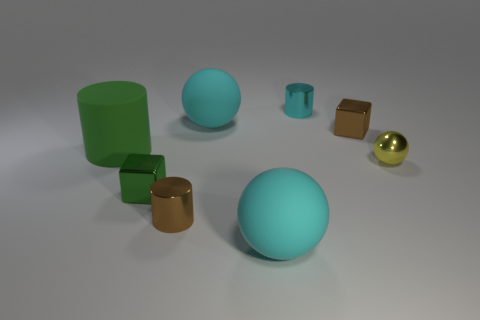Subtract all red cylinders. How many cyan spheres are left? 2 Subtract all cyan balls. How many balls are left? 1 Add 1 tiny cyan metallic objects. How many objects exist? 9 Subtract all cylinders. How many objects are left? 5 Subtract all large blue matte spheres. Subtract all small cyan metal things. How many objects are left? 7 Add 2 small green things. How many small green things are left? 3 Add 4 tiny purple balls. How many tiny purple balls exist? 4 Subtract 0 yellow cylinders. How many objects are left? 8 